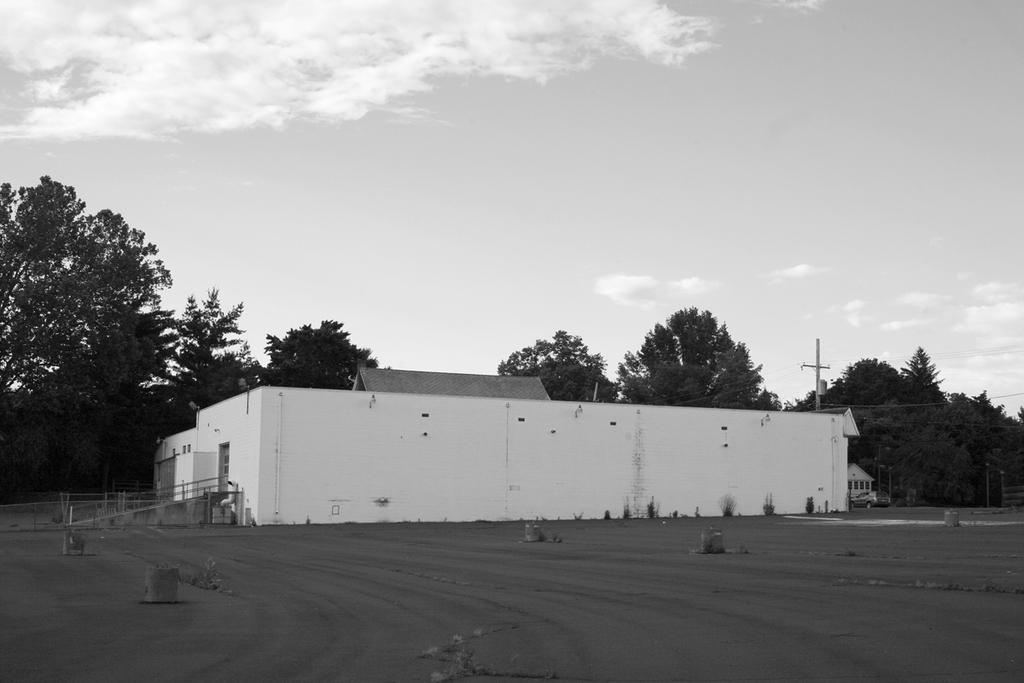What type of structure is present in the image? There is a building in the image. What other natural elements can be seen in the image? There are trees in the image. What object is standing upright in the image? There is a pole in the image. What is visible in the sky in the image? Clouds are visible in the image. How is the image presented in terms of color? The image is in black and white. What type of beast can be seen rubbing against the building in the image? There is no beast present in the image, and therefore no such activity can be observed. What holiday is being celebrated in the image? The image does not depict any holiday or celebration. 